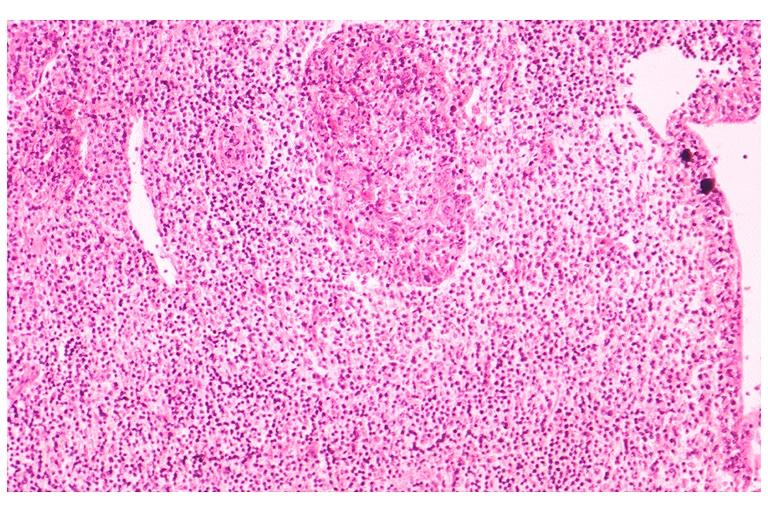what does this image show?
Answer the question using a single word or phrase. Sjogrens syndrome 